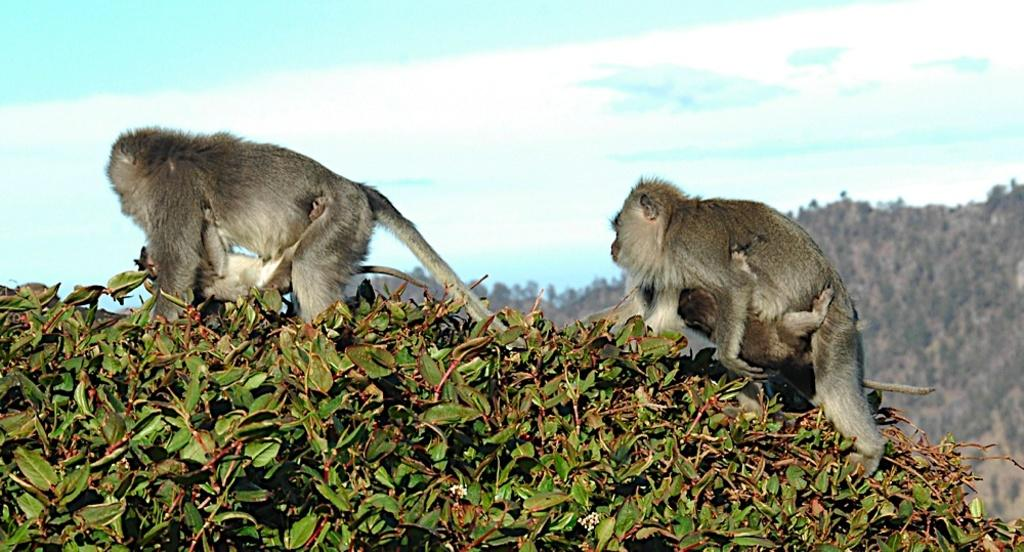How many monkeys are in the image? There are two monkeys in the image. What are the monkeys doing in the image? The monkeys have babies with them and are crawling on the planet surface. What can be seen in the background of the image? There is a hill and the sky visible in the background of the image. What is the condition of the sky in the image? Clouds are present in the sky. What type of structure can be seen in the image? There is no structure present in the image; it features two monkeys with their babies crawling on a planet surface. What instrument is the monkey playing in the image? There is no instrument present in the image; the monkeys are crawling with their babies. 